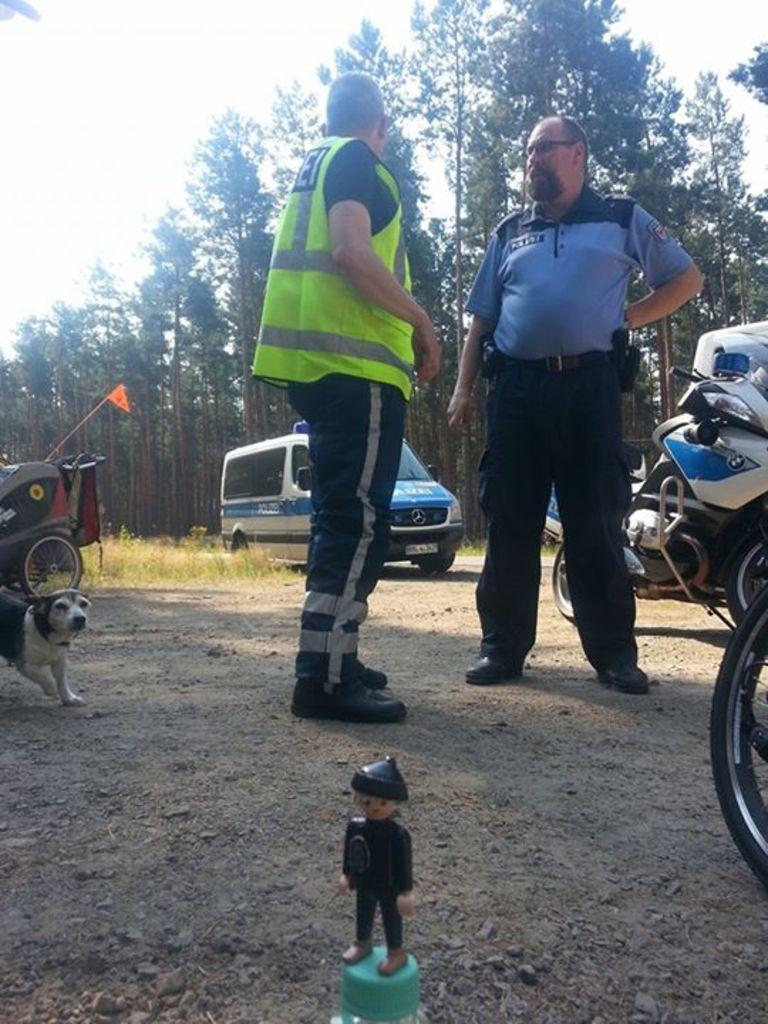How would you summarize this image in a sentence or two? In this image we can see people standing. On the left there is a dog and we can see vehicles. At the bottom there is a figurine. In the background there are trees and sky. 